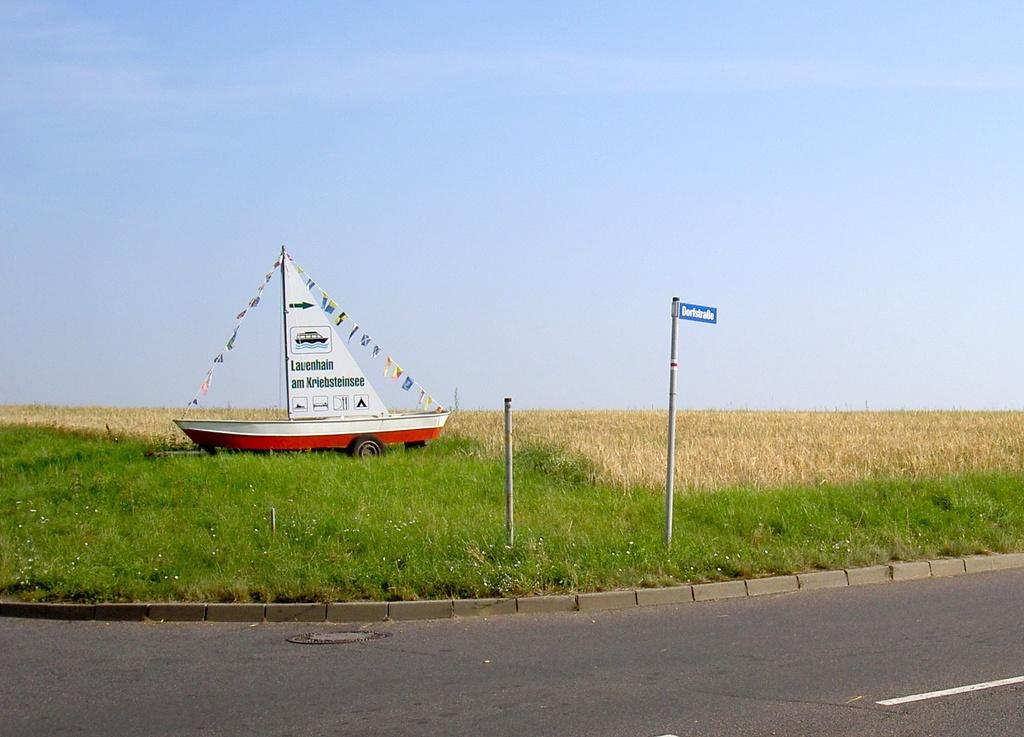What is the main object in the image? There is a sign board in the image. What type of material is used for the metal rods in the image? The metal rods in the image are made of metal. Where is the boat located in the image? The boat is on the grass in the image. What can be seen in the distance in the image? There is a field visible in the background of the image. What is the taste of the lace in the image? There is no lace present in the image, and therefore no taste can be determined. 